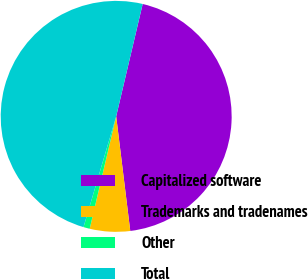<chart> <loc_0><loc_0><loc_500><loc_500><pie_chart><fcel>Capitalized software<fcel>Trademarks and tradenames<fcel>Other<fcel>Total<nl><fcel>44.37%<fcel>5.63%<fcel>0.88%<fcel>49.12%<nl></chart> 